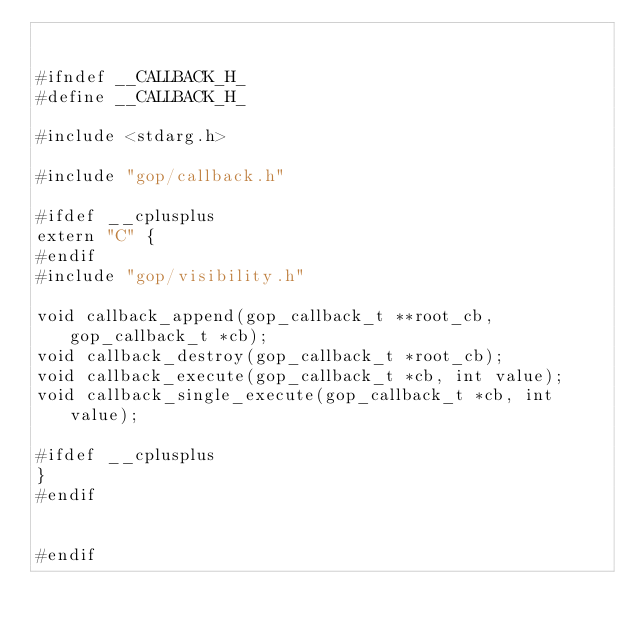<code> <loc_0><loc_0><loc_500><loc_500><_C_>

#ifndef __CALLBACK_H_
#define __CALLBACK_H_

#include <stdarg.h>

#include "gop/callback.h"

#ifdef __cplusplus
extern "C" {
#endif
#include "gop/visibility.h"

void callback_append(gop_callback_t **root_cb, gop_callback_t *cb);
void callback_destroy(gop_callback_t *root_cb);
void callback_execute(gop_callback_t *cb, int value);
void callback_single_execute(gop_callback_t *cb, int value);

#ifdef __cplusplus
}
#endif


#endif

</code> 